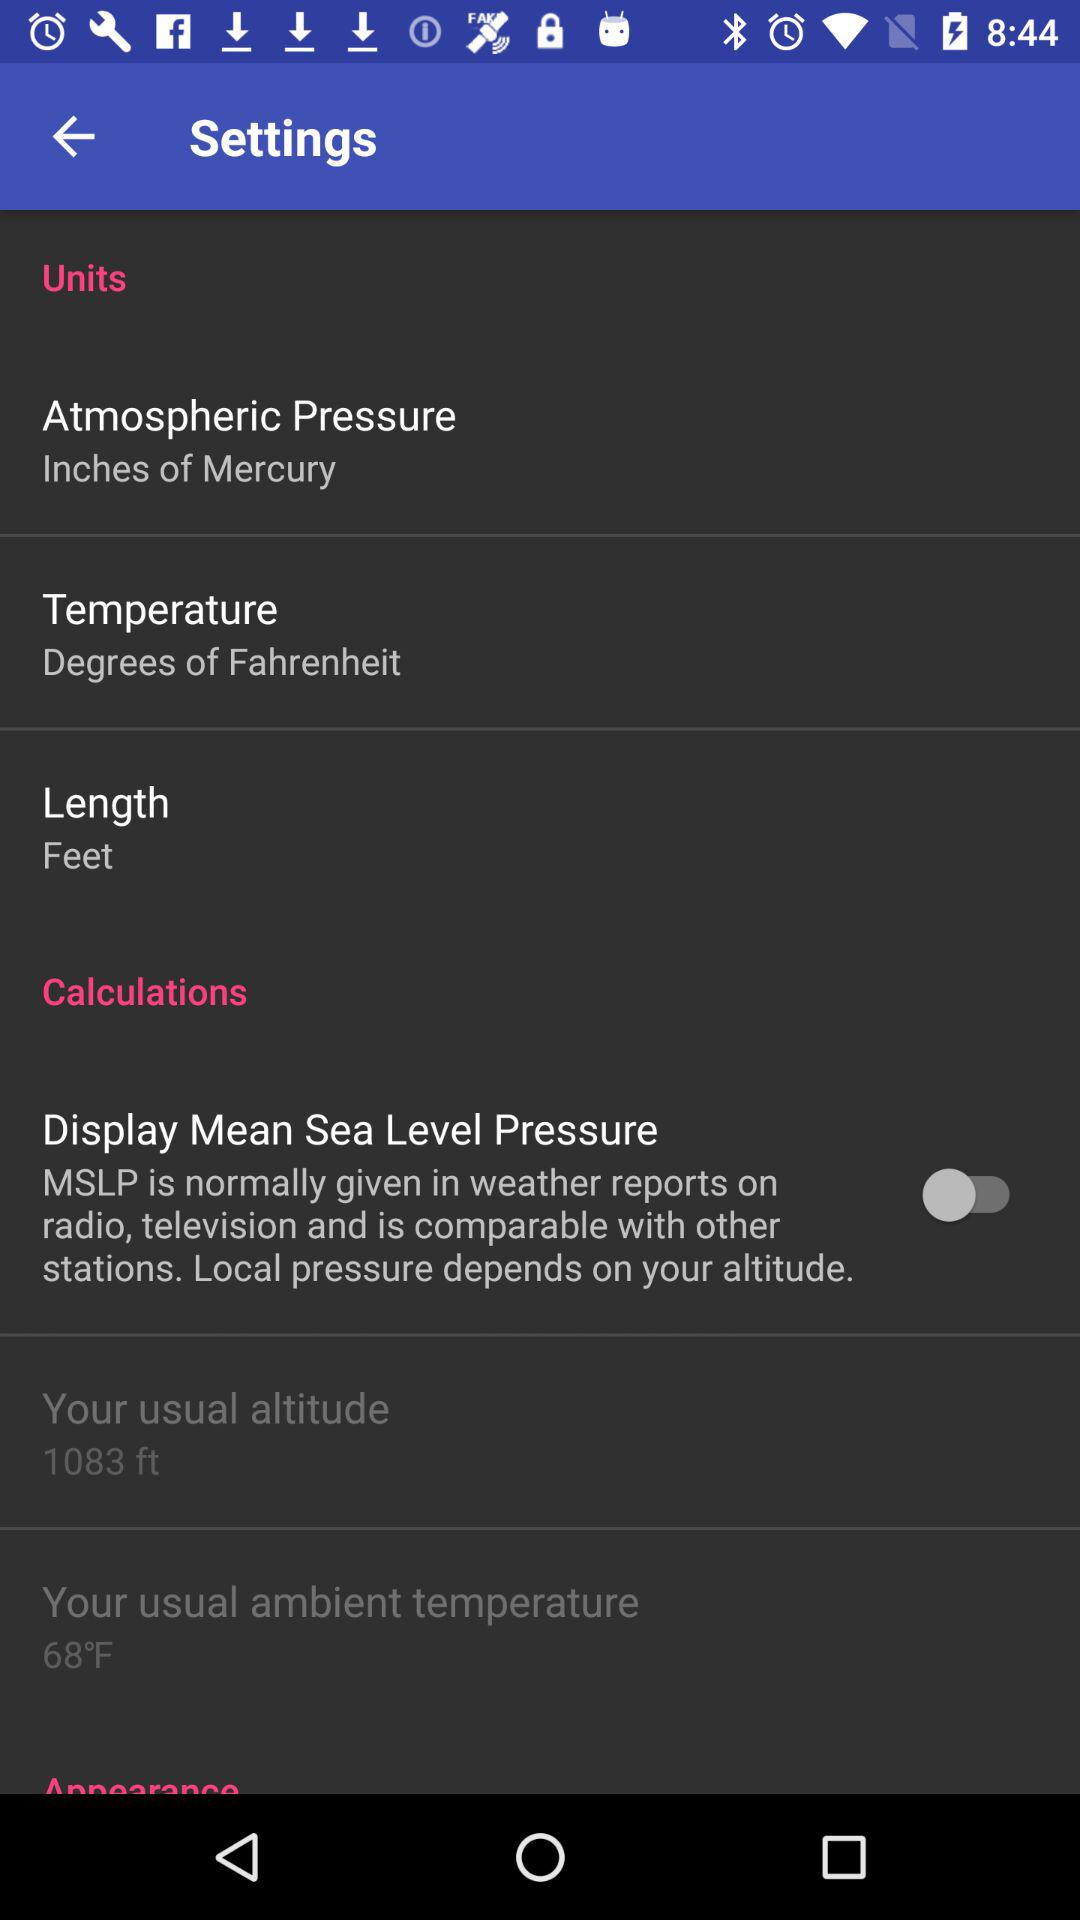What is the status of "Display Mean Sea Level Pressure"? The status is "off". 